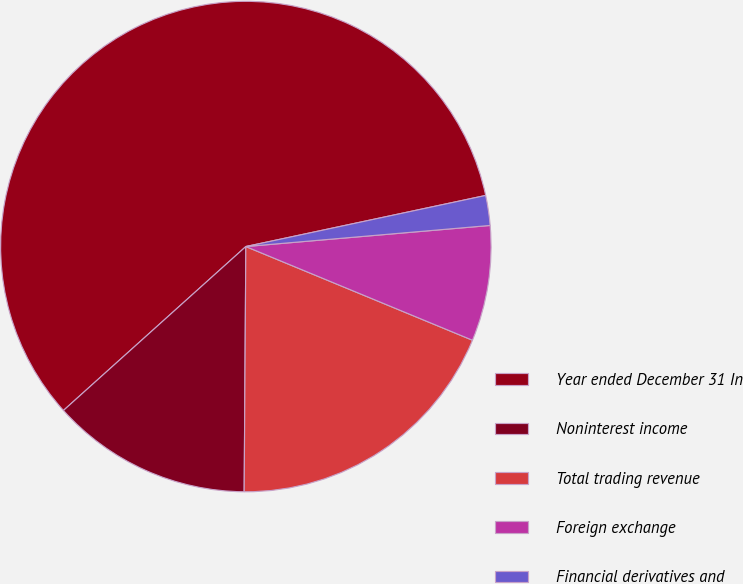Convert chart. <chart><loc_0><loc_0><loc_500><loc_500><pie_chart><fcel>Year ended December 31 In<fcel>Noninterest income<fcel>Total trading revenue<fcel>Foreign exchange<fcel>Financial derivatives and<nl><fcel>58.31%<fcel>13.24%<fcel>18.87%<fcel>7.61%<fcel>1.97%<nl></chart> 